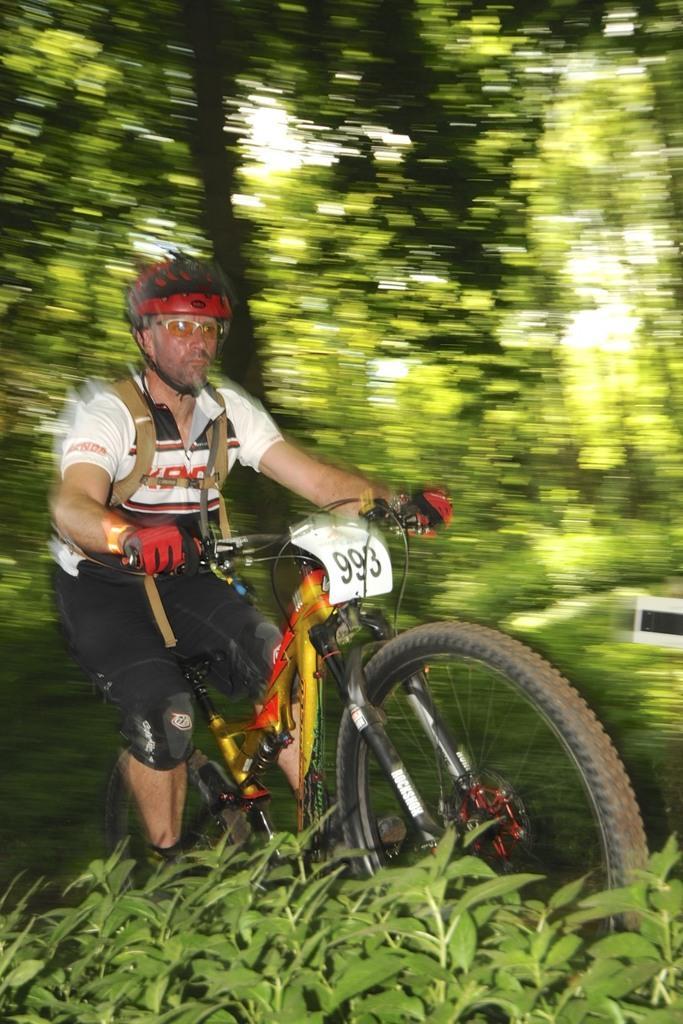Could you give a brief overview of what you see in this image? In the middle of this image, there is a person in a white color t-shirt, cycling on the road. At the bottom of this image, there are plants. In the background, there are trees and plants on the ground and there is sky. 